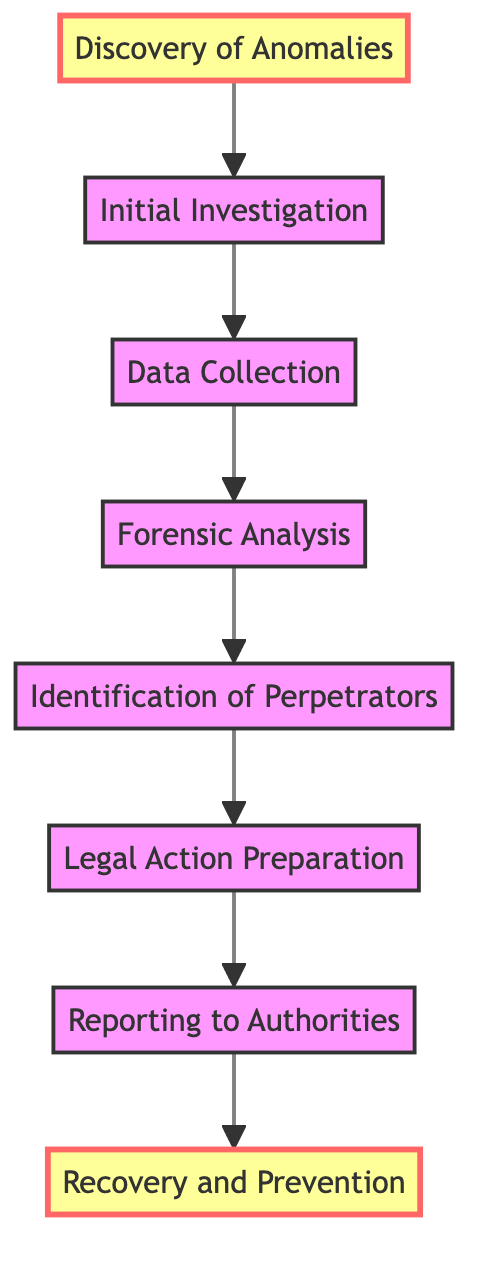What is the first step in uncovering a financial fraud incident? The diagram indicates that the first step is "Discovery of Anomalies," which is where unusual transaction patterns are noticed.
Answer: Discovery of Anomalies How many total steps are outlined in the flow chart? By counting the boxes in the flow chart, there are eight steps: Discovery of Anomalies, Initial Investigation, Data Collection, Forensic Analysis, Identification of Perpetrators, Legal Action Preparation, Reporting to Authorities, and Recovery and Prevention.
Answer: Eight What follows "Data Collection" in the diagram? Looking at the flow direction, "Forensic Analysis" is the step that immediately follows "Data Collection."
Answer: Forensic Analysis Which step leads to Reporting to Authorities? By tracing the flow from "Legal Action Preparation," it leads directly to "Reporting to Authorities."
Answer: Legal Action Preparation What is the last step in the financial fraud incident process? The last step evidenced in the flow chart is "Recovery and Prevention." This indicates measures to retrieve lost funds and prevent future fraud.
Answer: Recovery and Prevention What type of entities are involved in the Forensic Analysis step? The diagram specifies that "Forensic Accountants" and "Data Scientists" are the real-world entities involved in the "Forensic Analysis" step.
Answer: Forensic Accountants, Data Scientists Which steps are highlighted in the diagram? The highlighted steps in the diagram are "Discovery of Anomalies" and "Recovery and Prevention," indicating their significance in the process.
Answer: Discovery of Anomalies, Recovery and Prevention What is the relationship between "Identification of Perpetrators" and "Legal Action Preparation"? The flowchart shows a direct connection where "Identification of Perpetrators" leads directly into "Legal Action Preparation," indicating a process sequence.
Answer: Identification of Perpetrators leads to Legal Action Preparation In terms of direction, what does the arrow indicate in this bottom to top flow chart? The arrow indicates a progression that moves from the initial step at the bottom to the final step at the top, illustrating the sequential process of uncovering financial fraud.
Answer: Progression from initial to final step 